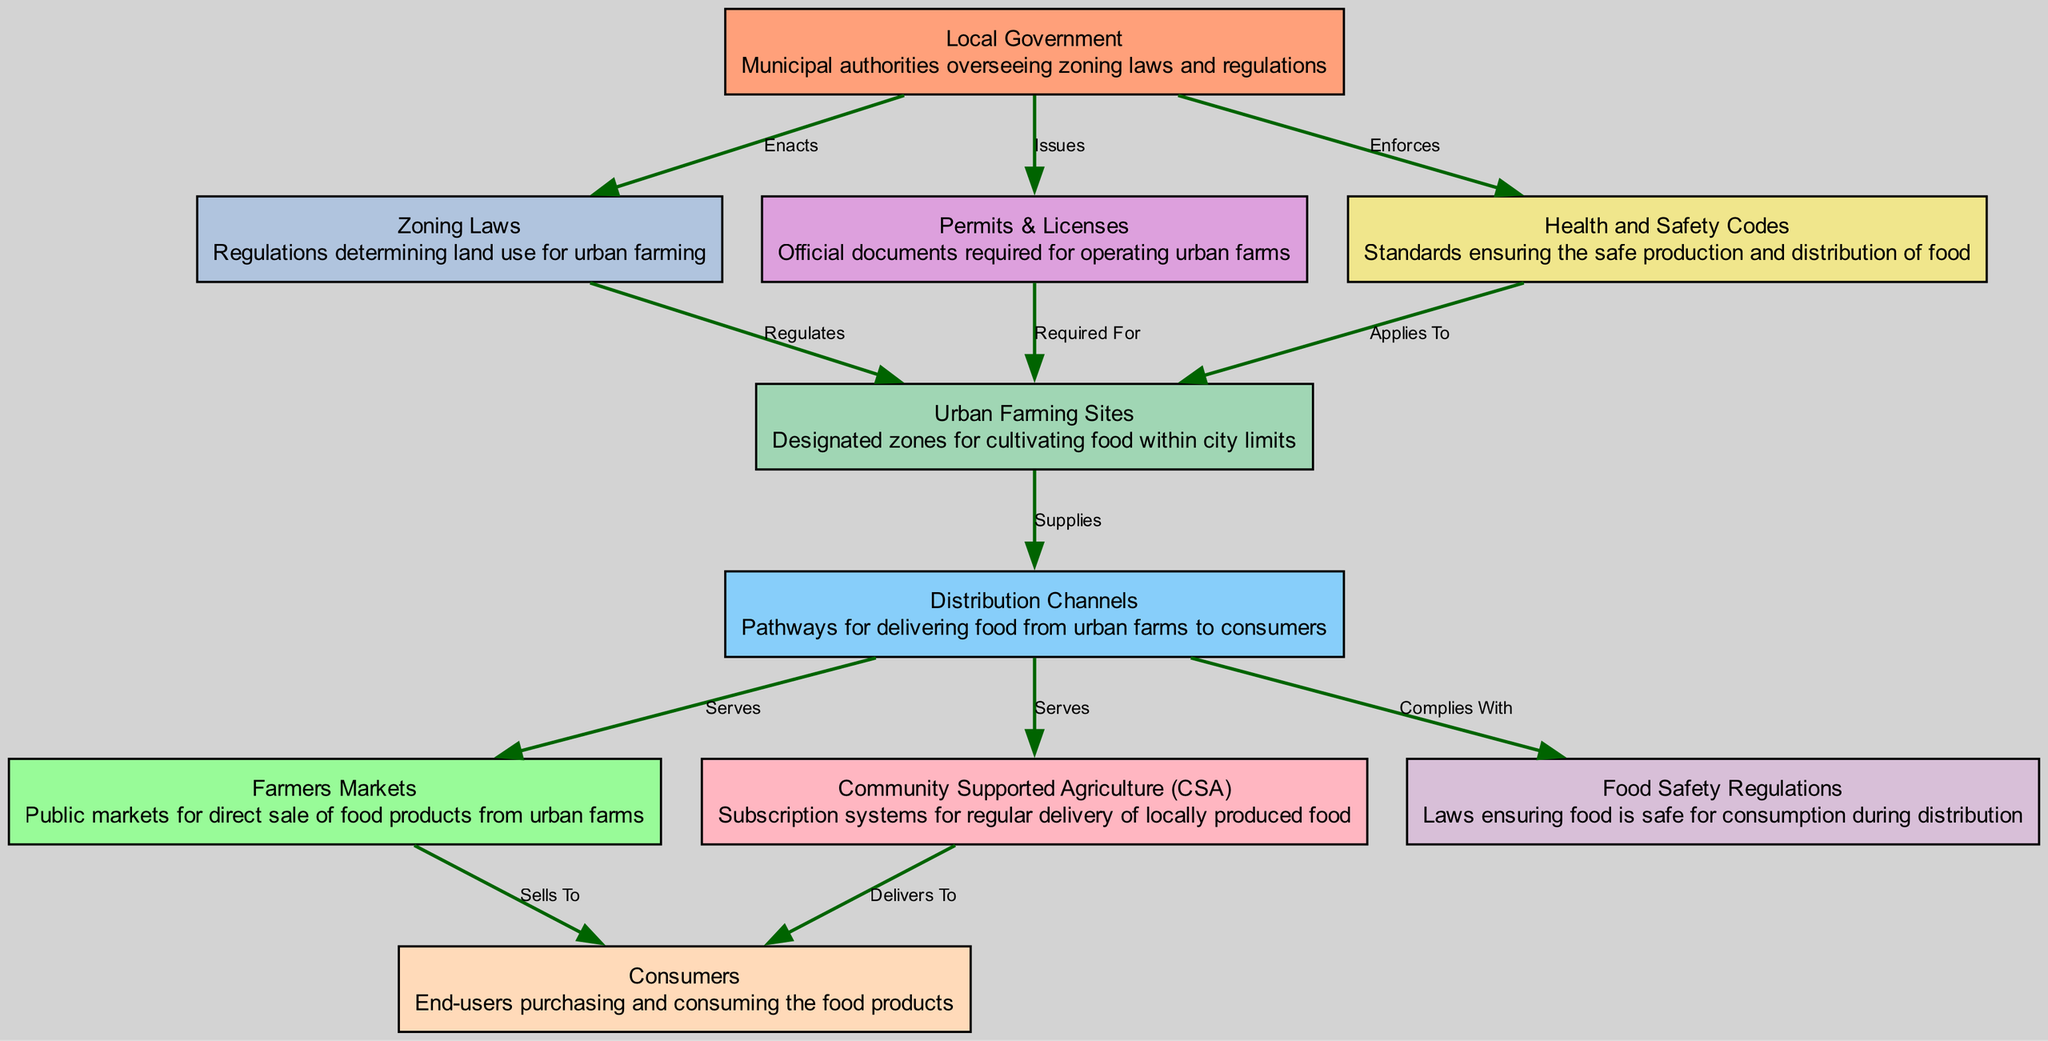What are Urban Farming Sites? Urban Farming Sites are designated zones for cultivating food within city limits. They are represented as a node in the diagram and are essential for urban agriculture initiatives.
Answer: Designated zones for cultivating food within city limits Who enacts Zoning Laws? Zoning Laws are enacted by the Local Government. The diagram shows a direct connection where the Local Government node points to Zoning Laws node with the label "Enacts".
Answer: Local Government How many edges connect to Distribution Channels? The Distribution Channels node is connected to three other nodes in the diagram. These include Farmers Markets, Community Supported Agriculture (CSA), and Food Safety Regulations.
Answer: 3 Which node supplies Distribution Channels? The node that supplies Distribution Channels is Urban Farming Sites. The connection is represented in the diagram as a direct relationship with the label "Supplies".
Answer: Urban Farming Sites What is required for Urban Farming Sites? Permits & Licenses are required for Urban Farming Sites, as indicated by the relationship showing that Permits & Licenses is connected to Urban Farming Sites with the label "Required For".
Answer: Permits & Licenses Who sells to Consumers? Farmers Markets sell to Consumers in the outlined flow of the diagram. This is evidenced by the edge connecting the Farmers Markets to the Consumers with the label "Sells To".
Answer: Farmers Markets What do Health and Safety Codes apply to? Health and Safety Codes apply to Urban Farming Sites. This relationship shows that the Health and Safety Codes node connects to Urban Farming Sites, indicating its regulation and enforcement in those areas.
Answer: Urban Farming Sites What kind of regulations ensure food safety during distribution? Food Safety Regulations are the laws that ensure food is safe for consumption during distribution as shown by the connection from Distribution Channels to Food Safety Regulations labeled "Complies With".
Answer: Food Safety Regulations How many total nodes are in this diagram? The diagram consists of ten nodes, each representing different aspects of urban farming and food distribution. The count can be directly observed from the nodes listed in the diagram.
Answer: 10 